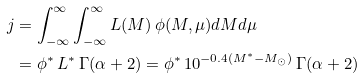<formula> <loc_0><loc_0><loc_500><loc_500>j & = \int ^ { \infty } _ { - \infty } \int ^ { \infty } _ { - \infty } L ( M ) \, \phi ( M , \mu ) d M d \mu \\ & = \phi ^ { * } \, L ^ { * } \, \Gamma ( \alpha + 2 ) = \phi ^ { * } \, 1 0 ^ { - 0 . 4 ( M ^ { * } - M _ { \odot } ) } \, \Gamma ( \alpha + 2 ) \\</formula> 